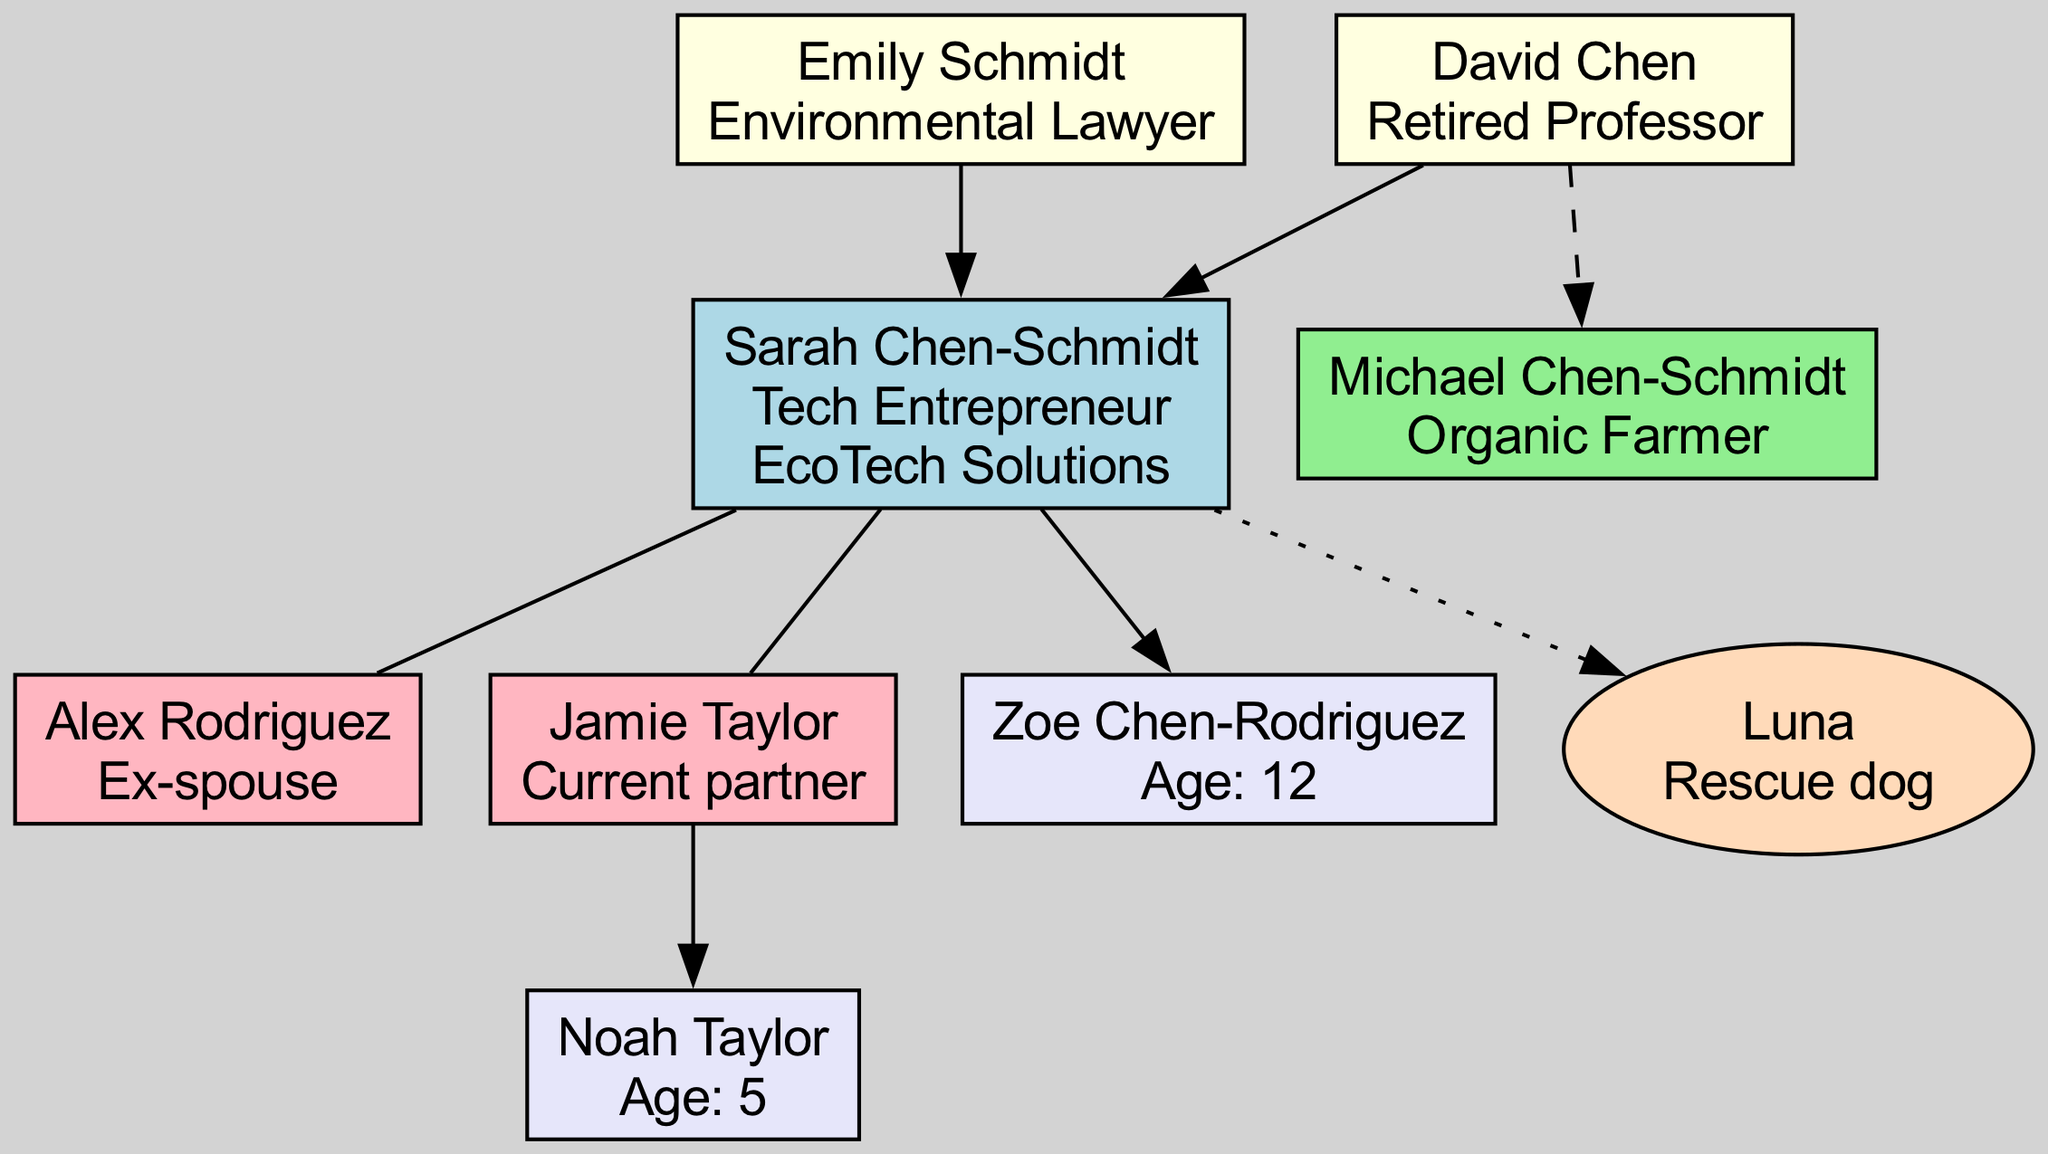What is the occupation of Sarah Chen-Schmidt? The diagram shows Sarah Chen-Schmidt at the root node, and her occupation is listed as "Tech Entrepreneur."
Answer: Tech Entrepreneur Who are the parents of Sarah Chen-Schmidt? The diagram depicts two parental nodes connected to the root node. Their names are "David Chen" and "Emily Schmidt."
Answer: David Chen, Emily Schmidt How many siblings does Sarah Chen-Schmidt have? The diagram indicates that there is one sibling node connected to the parent node. Hence, the count of siblings is one.
Answer: 1 What is the name of Sarah's current partner? In the diagram, there is a node labeled under partners that shows the name "Jamie Taylor," specifying the relationship as "Current partner."
Answer: Jamie Taylor How many children does Sarah Chen-Schmidt have? The diagram indicates two child nodes connected to the root node. Thus, the total number of children is two.
Answer: 2 What is the age of Noah Taylor? The child node for Noah Taylor specifically states "Age: 5," indicating his age in the diagram.
Answer: 5 Which pet is associated with Sarah Chen-Schmidt? The diagram includes a pet node that names the pet "Luna" and describes it as a "Rescue dog."
Answer: Luna What is the relationship between Sarah and Zoe? The diagram shows a child node for Zoe Chen-Rodriguez connected to the root node indicating she is a child of Sarah Chen-Schmidt.
Answer: Parent-Child Which family member is an organic farmer? The diagram contains a sibling node that describes the occupation of the sibling as "Organic Farmer."
Answer: Michael Chen-Schmidt 